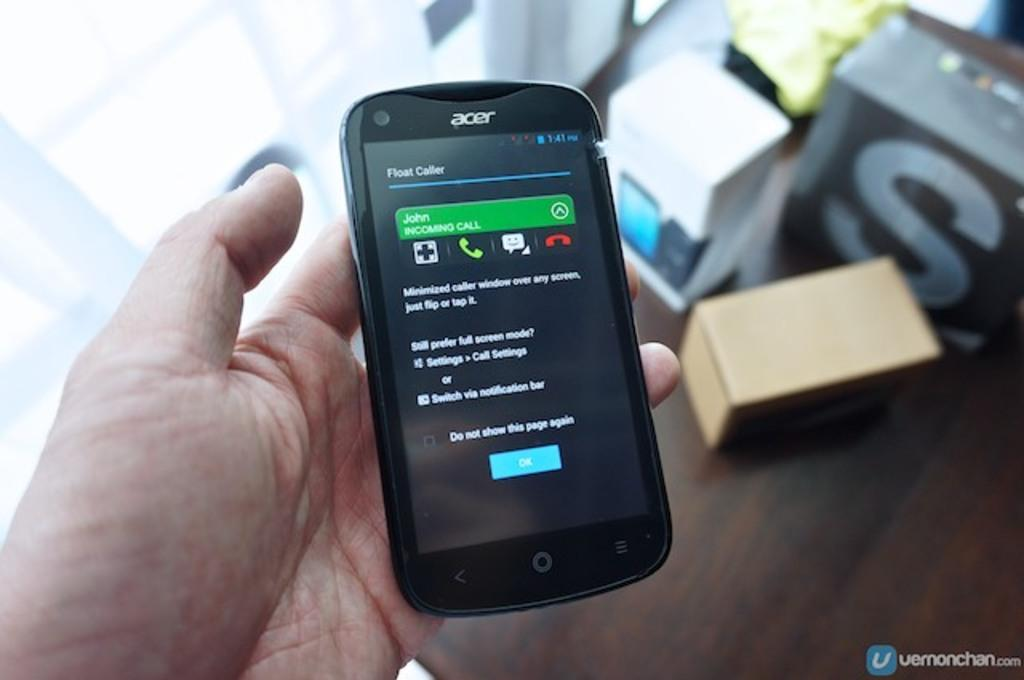What is being held by the person's hand in the image? There is a person's hand holding a mobile in the image. What objects can be seen on the floor in the image? There are cartons placed on the floor in the image. What can be seen in the background of the image? There is a window visible in the background of the image. What type of fiction is the person reading from the mobile in the image? There is no indication in the image that the person is reading fiction or any other type of content from the mobile. 